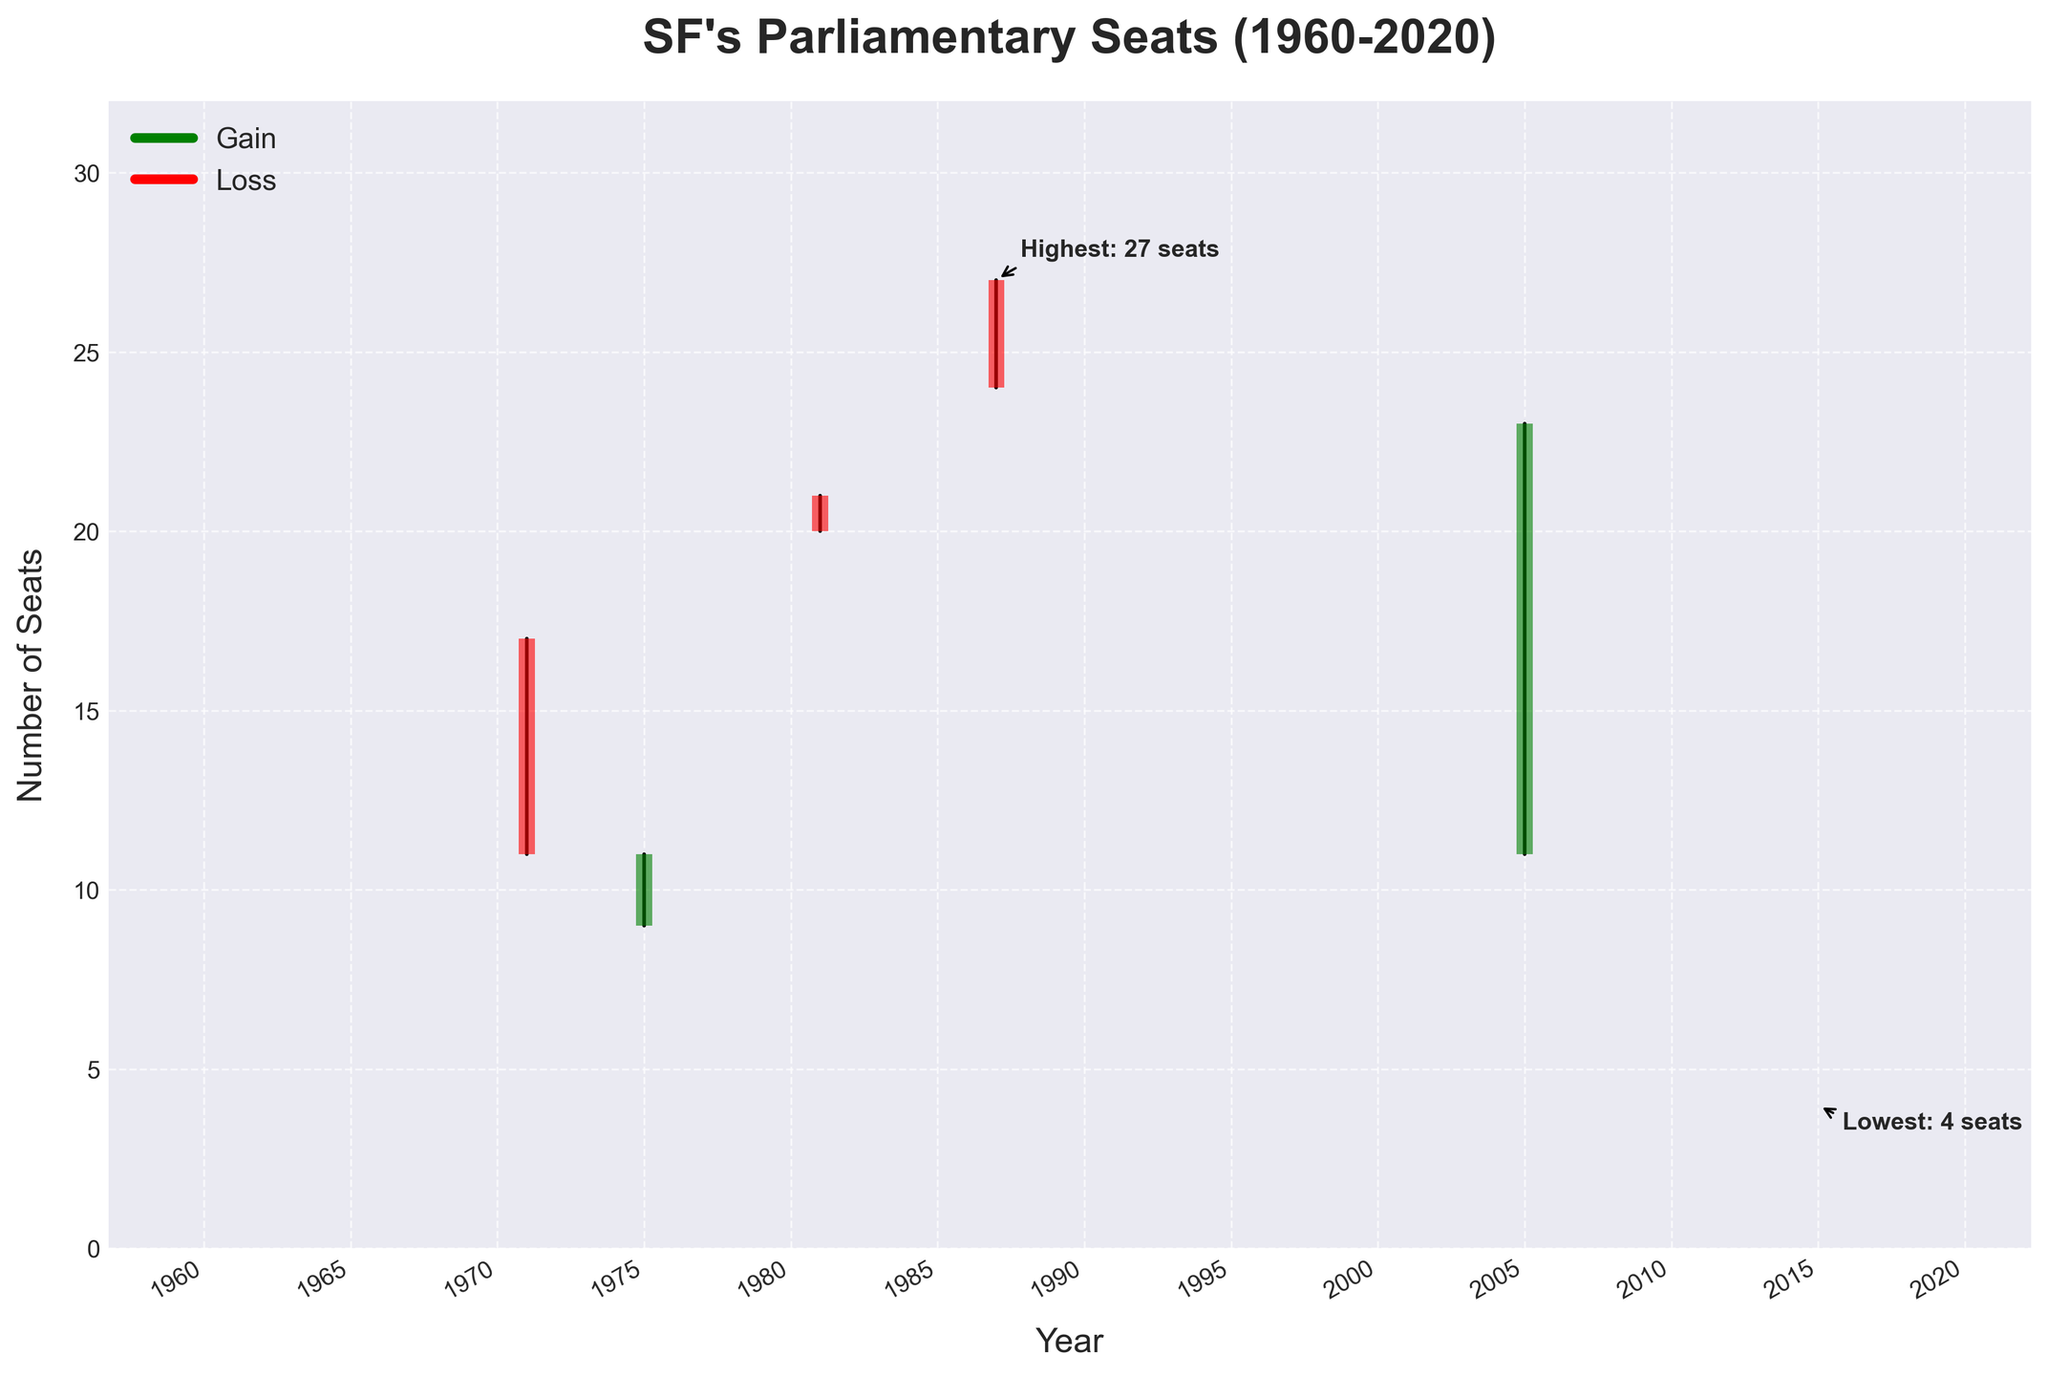What is the title of the chart? The title is typically shown at the top of the chart. In this case, it summarizes the subject of the data presented: "SF's Parliamentary Seats (1960-2020)."
Answer: SF's Parliamentary Seats (1960-2020) How many years are covered in this chart? This can be determined by counting the data points listed on the x-axis or by looking at the year range in the chart. The data spans from 1960 to 2019.
Answer: 60 years Which year saw the highest number of parliamentary seats for SF? The highest number of seats is annotated in the chart. The annotation shows "Highest: 27 seats" for the year where the high was observed, which is 1987.
Answer: 1987 What was the lowest number of seats recorded, and in which year did it occur? The lowest number of seats is annotated in the chart. The annotation shows "Lowest: 4 seats," which occurred in 2015.
Answer: 4 seats in 2015 In which year did SF experience the highest gain (increase from open to close)? To find the highest gain, look for the year with the greatest vertical difference where the close is higher than the open, which is marked by a green bar. The year 2005 shows SF moving from 11 to 23 seats, an increase of 12 seats.
Answer: 2005 In which year did SF experience the greatest loss (decrease from open to close)? To identify the greatest loss, observe the year with the greatest vertical difference where the close is lower than the open, indicated by a red bar. This is not present in the data; all red bars show an equal loss.
Answer: None What years have the same opening and closing values for SF's parliamentary seats? If the bar segments are thin or not colored (apart from the high-low line), the opening and closing values are the same. Years such as 1960, 1964, 1977, 1988, 1990, and 2011 reflect this pattern.
Answer: 1960, 1964, 1977, 1988, 1990, 2011 How many times did the number of parliamentary seats drop below 10? Note the years where the low seat value is less than 10, indicated on the y-axis. This occurred in 1964, 1975, and 1977.
Answer: 3 times What is the average number of seats in the highest year and the lowest year? To find the average, sum the number of seats in the highest and lowest years and divide by two. Here, 27 (highest, 1987) + 4 (lowest, 2015) = 31, and 31/2 = 15.5.
Answer: 15.5 